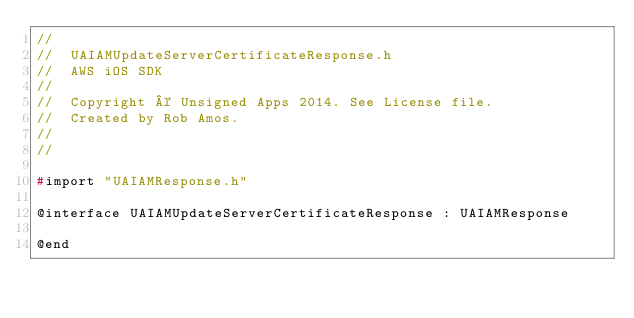Convert code to text. <code><loc_0><loc_0><loc_500><loc_500><_C_>//
//  UAIAMUpdateServerCertificateResponse.h
//  AWS iOS SDK
//
//  Copyright © Unsigned Apps 2014. See License file.
//  Created by Rob Amos.
//
//

#import "UAIAMResponse.h"

@interface UAIAMUpdateServerCertificateResponse : UAIAMResponse

@end
</code> 